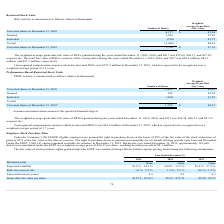According to Cornerstone Ondemand's financial document, What was the weighted-average grant date fair value of PRSUs granted in 2017? According to the financial document, $41.73. The relevant text states: "r 31, 2019, 2018, and 2017 was $56.74, $40.53, and $41.73,..." Also, What was the unrecognized compensation expense related to unvested PRSUs in 2019? According to the financial document, $16.9 million. The relevant text states: "compensation expense related to unvested PRSUs was $16.9 million at December 31, 2019, which is expected to be recognized over a..." Also, What was the weighted-average grant date fair value of PRSUs granted in 2018? According to the financial document, $40.53. The relevant text states: "nded December 31, 2019, 2018, and 2017 was $56.74, $40.53, and $41.73,..." Also, can you calculate: What is the difference in weighted-average grant date fair value between granted and forfeited shares? Based on the calculation: (56.74-41.29), the result is 15.45. This is based on the information: "Forfeited (562) 41.29 Granted 390 56.74..." The key data points involved are: 41.29, 56.74. Also, can you calculate: What is the sum of number of unvested shares in 2018 and number of granted shares? Based on the calculation: (1,924+390), the result is 2314 (in thousands). This is based on the information: "Granted 390 56.74 Unvested shares at December 31, 2018 1,924 $ 40.81..." The key data points involved are: 1,924, 390. Also, can you calculate: What is the change in number of unvested shares between 2018 and 2019? Based on the calculation: (1,752-1,924), the result is -172 (in thousands). This is based on the information: "Unvested shares at December 31, 2019 1 1,752 $ 44.21 Unvested shares at December 31, 2018 1,924 $ 40.81..." The key data points involved are: 1,752, 1,924. 